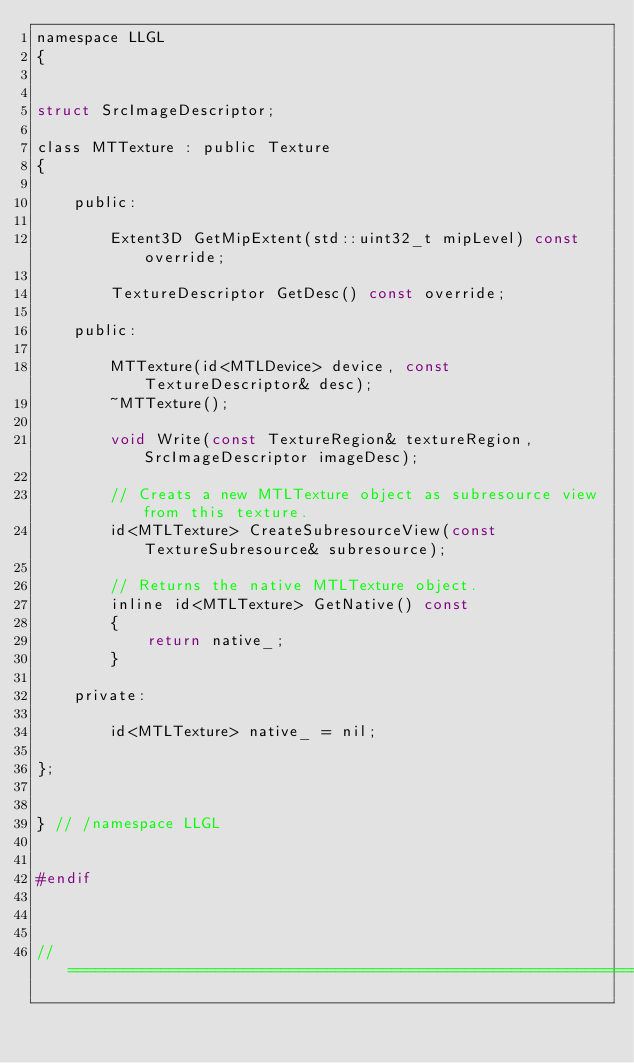Convert code to text. <code><loc_0><loc_0><loc_500><loc_500><_C_>namespace LLGL
{


struct SrcImageDescriptor;

class MTTexture : public Texture
{

    public:

        Extent3D GetMipExtent(std::uint32_t mipLevel) const override;

        TextureDescriptor GetDesc() const override;

    public:

        MTTexture(id<MTLDevice> device, const TextureDescriptor& desc);
        ~MTTexture();

        void Write(const TextureRegion& textureRegion, SrcImageDescriptor imageDesc);

        // Creats a new MTLTexture object as subresource view from this texture.
        id<MTLTexture> CreateSubresourceView(const TextureSubresource& subresource);

        // Returns the native MTLTexture object.
        inline id<MTLTexture> GetNative() const
        {
            return native_;
        }

    private:

        id<MTLTexture> native_ = nil;

};


} // /namespace LLGL


#endif



// ================================================================================
</code> 